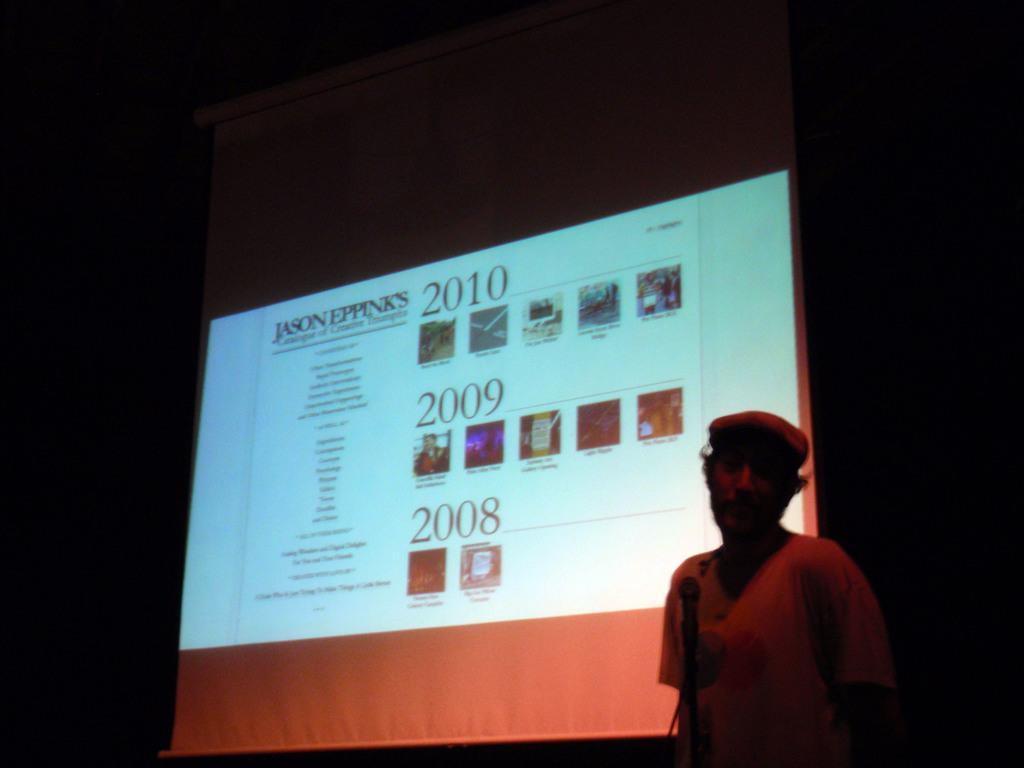Could you give a brief overview of what you see in this image? In this image we can see a person and a mike. There is a dark background and we can see a screen. 